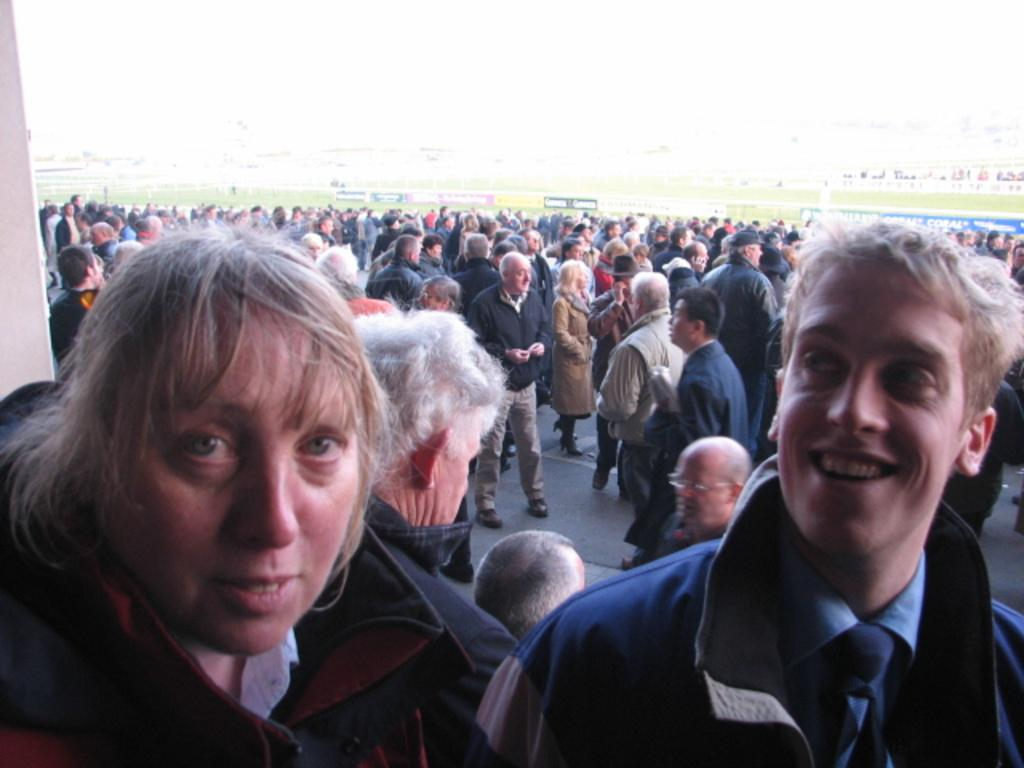Who are the people in the image? There is a woman and a man in the image. Where are the woman and man located in the image? Both the woman and man are at the bottom of the image. What can be seen in the background of the image? There is a crowd visible in the background of the image. What type of cracker is the woman holding in the image? There is no cracker present in the image. How many tickets does the man have in the image? There is no ticket present in the image. Is there a kettle visible in the image? There is no kettle present in the image. 